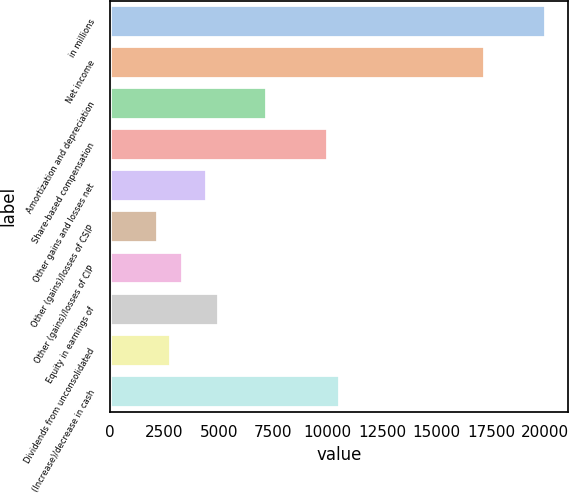Convert chart. <chart><loc_0><loc_0><loc_500><loc_500><bar_chart><fcel>in millions<fcel>Net income<fcel>Amortization and depreciation<fcel>Share-based compensation<fcel>Other gains and losses net<fcel>Other (gains)/losses of CSIP<fcel>Other (gains)/losses of CIP<fcel>Equity in earnings of<fcel>Dividends from unconsolidated<fcel>(Increase)/decrease in cash<nl><fcel>20033.9<fcel>17251.6<fcel>7235.28<fcel>10017.6<fcel>4452.98<fcel>2227.14<fcel>3340.06<fcel>5009.44<fcel>2783.6<fcel>10574<nl></chart> 